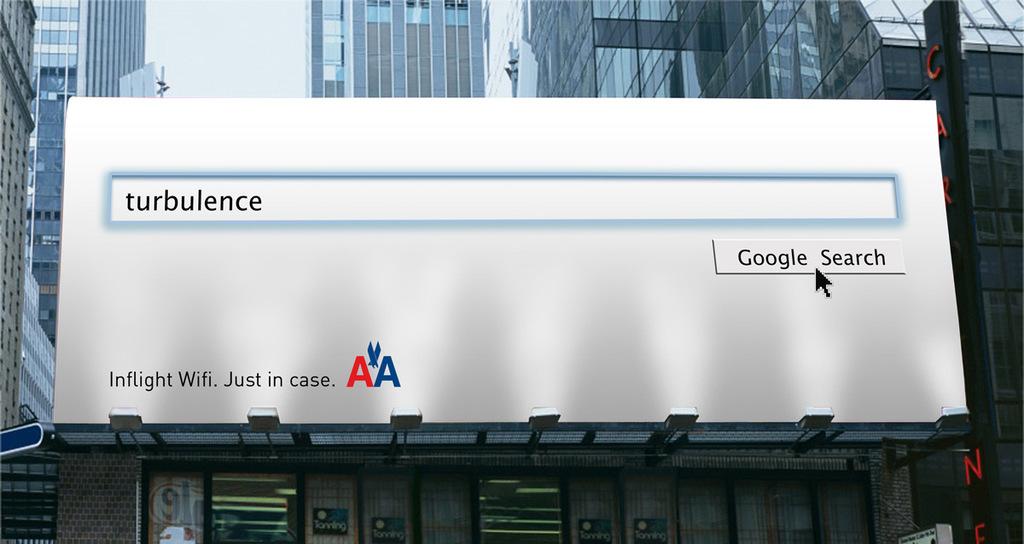What company is on the billboard?
Provide a succinct answer. Aa. What is the word in the search box on this billboard?
Offer a very short reply. Turbulence. 